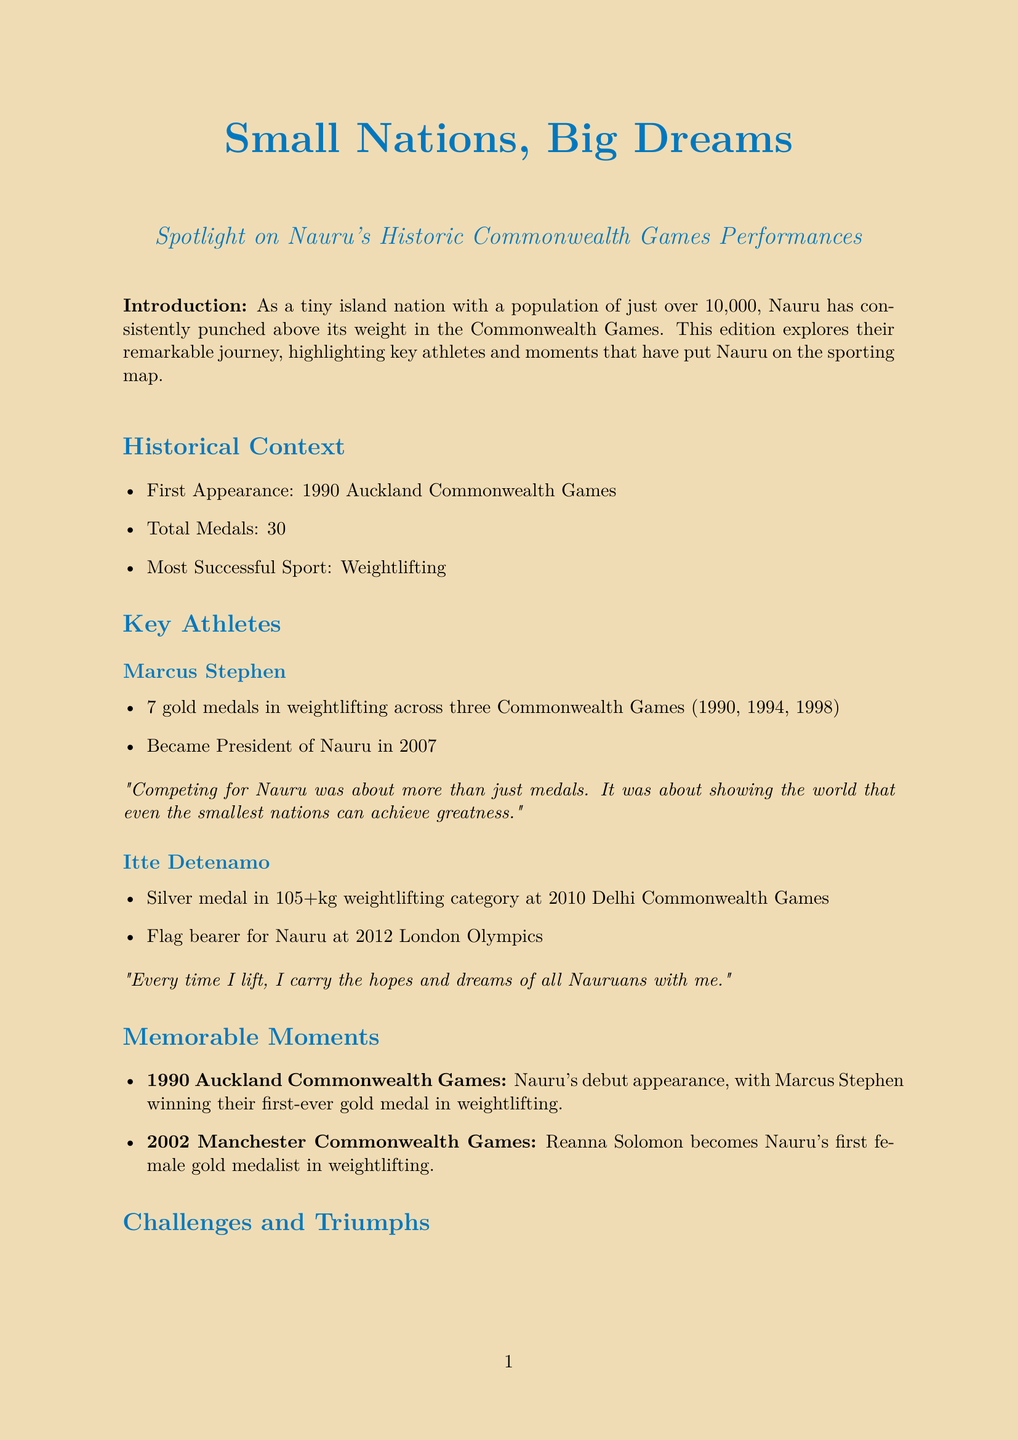What year did Nauru first compete in the Commonwealth Games? The document states that Nauru's first appearance was at the 1990 Auckland Commonwealth Games.
Answer: 1990 How many total medals has Nauru won in the Commonwealth Games? The total number of medals won by Nauru is listed as 30.
Answer: 30 Which sport is Nauru most successful in at the Commonwealth Games? The document notes that Nauru's most successful sport is weightlifting.
Answer: Weightlifting Who became President of Nauru in 2007? The document mentions that Marcus Stephen became President of Nauru in 2007.
Answer: Marcus Stephen What memorable achievement did Reanna Solomon accomplish in 2002? The document describes Reanna Solomon as Nauru's first female gold medalist in weightlifting at the 2002 Manchester Commonwealth Games.
Answer: First female gold medalist What challenges does Nauru face in athlete training? The document lists limited resources for athlete training and development as one of the challenges.
Answer: Limited resources What upcoming talent in weightlifting is mentioned for Nauru? The document identifies Charisma Amoe-Tarrant as an upcoming talent in weightlifting.
Answer: Charisma Amoe-Tarrant What was the significance of Nauru's debut in 1990? The document states that Marcus Stephen won Nauru's first-ever gold medal in weightlifting during their debut.
Answer: First-ever gold medal What future goals does Nauru aim to achieve in the Commonwealth Games? The document outlines that Nauru aims for continued success in weightlifting while expanding medal prospects in other sports.
Answer: Continued success in weightlifting 